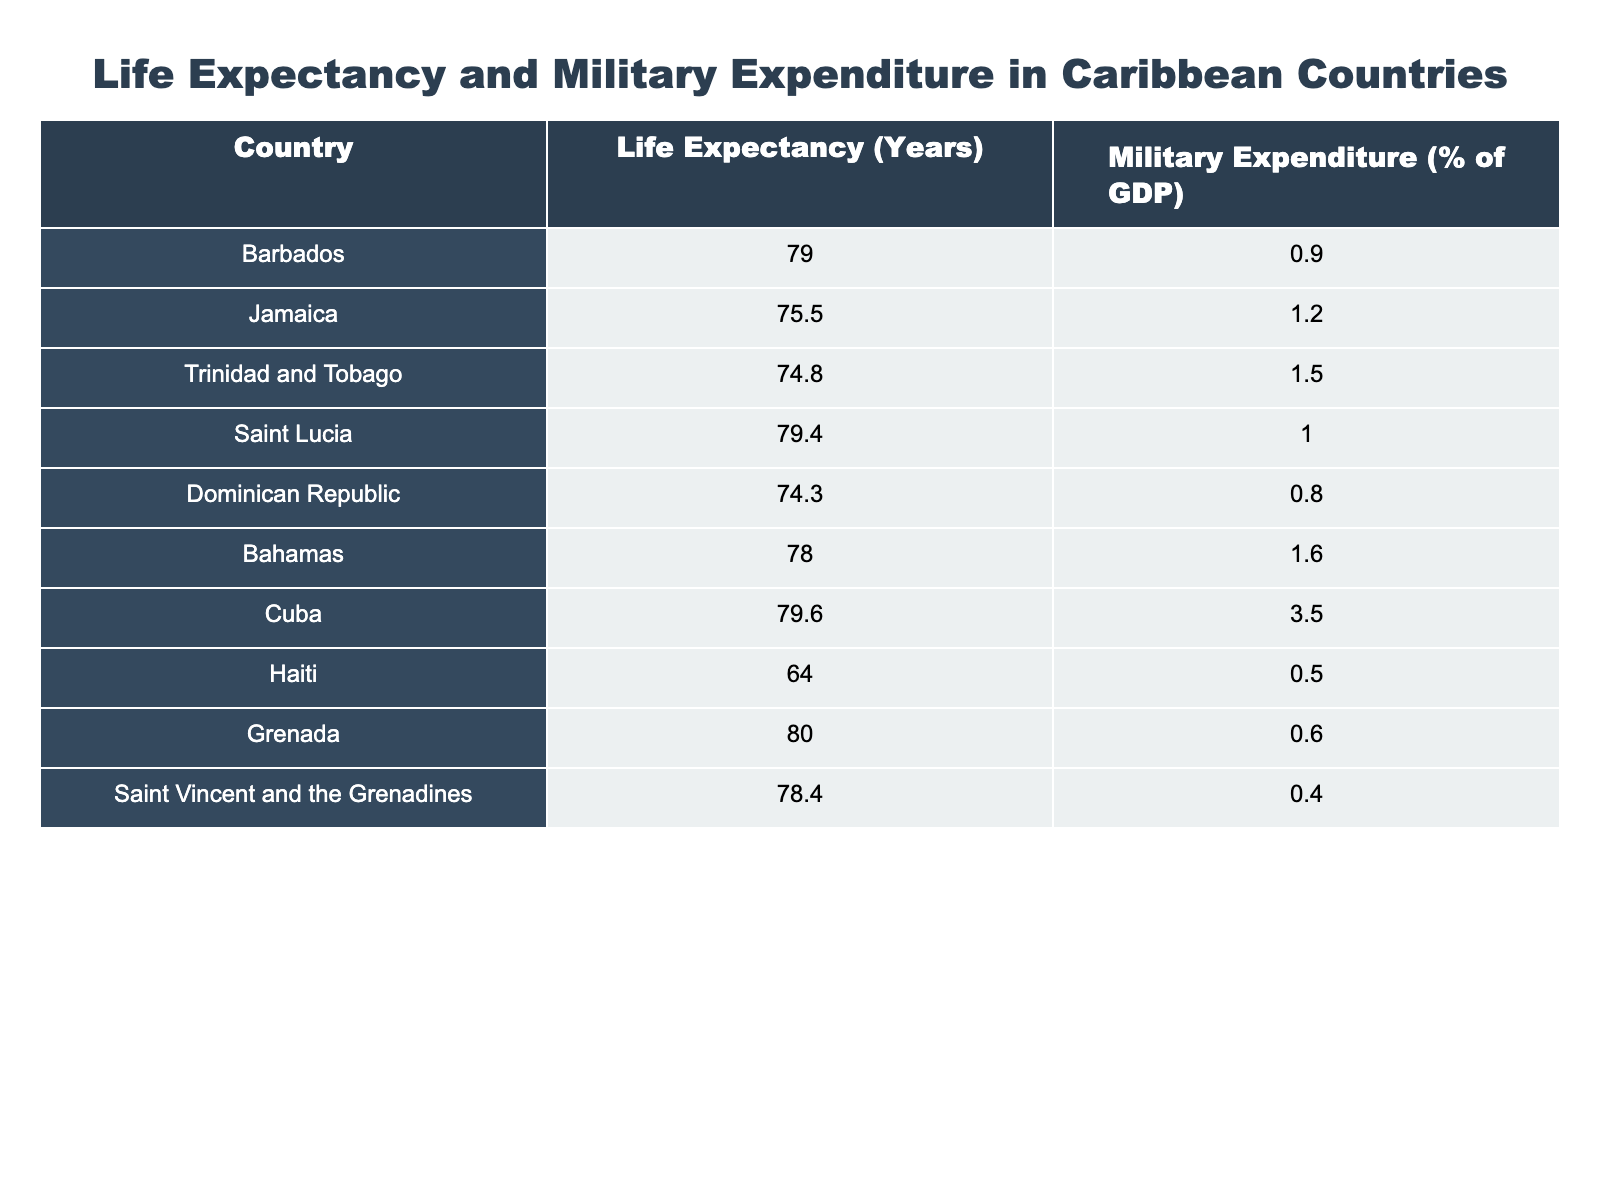What is the life expectancy of Barbados? The table lists the life expectancy for Barbados as 79.0 years.
Answer: 79.0 years Which country has the highest military expenditure as a percentage of GDP? The table indicates that Cuba has the highest military expenditure at 3.5% of GDP.
Answer: Cuba Is the life expectancy of Haiti greater than 70 years? The table shows that Haiti's life expectancy is 64.0 years, which is less than 70 years.
Answer: No What is the difference in life expectancy between Grenada and Jamaica? Grenada has a life expectancy of 80.0 years, while Jamaica's is 75.5 years. The difference is calculated as 80.0 - 75.5 = 4.5 years.
Answer: 4.5 years What is the average life expectancy of the countries listed in the table? To find the average, sum the life expectancies: (79.0 + 75.5 + 74.8 + 79.4 + 74.3 + 78.0 + 79.6 + 64.0 + 80.0 + 78.4) = 784.0. There are 10 countries, so the average is 784.0/10 = 78.4 years.
Answer: 78.4 years Which country has a life expectancy closest to the average calculated? The average life expectancy is 78.4 years. The countries closest to this value are Saint Vincent and the Grenadines with 78.4 years and Saint Lucia with 79.4 years, but Saint Vincent and the Grenadines matches exactly at 78.4 years.
Answer: Saint Vincent and the Grenadines Does Saint Lucia have a higher life expectancy than the Dominican Republic? The table indicates that Saint Lucia has a life expectancy of 79.4 years, while the Dominican Republic has a life expectancy of 74.3 years. Since 79.4 is greater than 74.3, the statement is true.
Answer: Yes What is the total military expenditure percentage for Jamaica and Trinidad and Tobago combined? Jamaica has a military expenditure of 1.2% of GDP and Trinidad and Tobago has 1.5% of GDP. Adding these together gives 1.2 + 1.5 = 2.7%.
Answer: 2.7% 